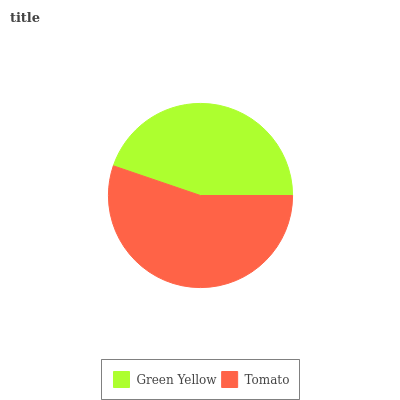Is Green Yellow the minimum?
Answer yes or no. Yes. Is Tomato the maximum?
Answer yes or no. Yes. Is Tomato the minimum?
Answer yes or no. No. Is Tomato greater than Green Yellow?
Answer yes or no. Yes. Is Green Yellow less than Tomato?
Answer yes or no. Yes. Is Green Yellow greater than Tomato?
Answer yes or no. No. Is Tomato less than Green Yellow?
Answer yes or no. No. Is Tomato the high median?
Answer yes or no. Yes. Is Green Yellow the low median?
Answer yes or no. Yes. Is Green Yellow the high median?
Answer yes or no. No. Is Tomato the low median?
Answer yes or no. No. 